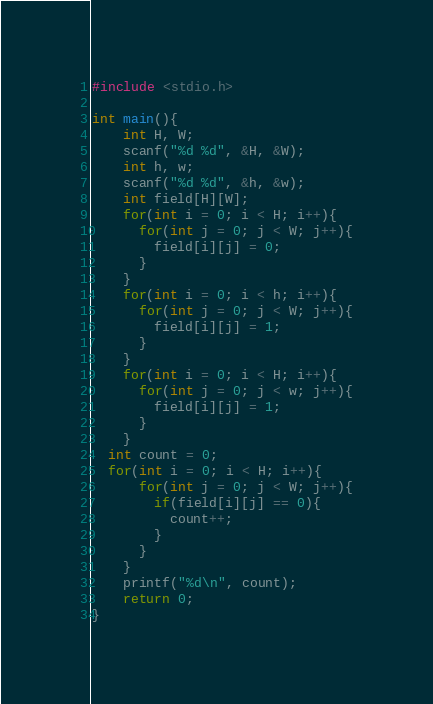<code> <loc_0><loc_0><loc_500><loc_500><_C_>#include <stdio.h>
 
int main(){
	int H, W;
  	scanf("%d %d", &H, &W);
  	int h, w;
  	scanf("%d %d", &h, &w);
  	int field[H][W];
  	for(int i = 0; i < H; i++){
      for(int j = 0; j < W; j++){
        field[i][j] = 0;
      }
    }
  	for(int i = 0; i < h; i++){
      for(int j = 0; j < W; j++){
        field[i][j] = 1;
      }
    }
  	for(int i = 0; i < H; i++){
      for(int j = 0; j < w; j++){
        field[i][j] = 1;
      }
    }
  int count = 0;
  for(int i = 0; i < H; i++){
      for(int j = 0; j < W; j++){
        if(field[i][j] == 0){
          count++;
        }
      }
    }
  	printf("%d\n", count);
	return 0;
}</code> 